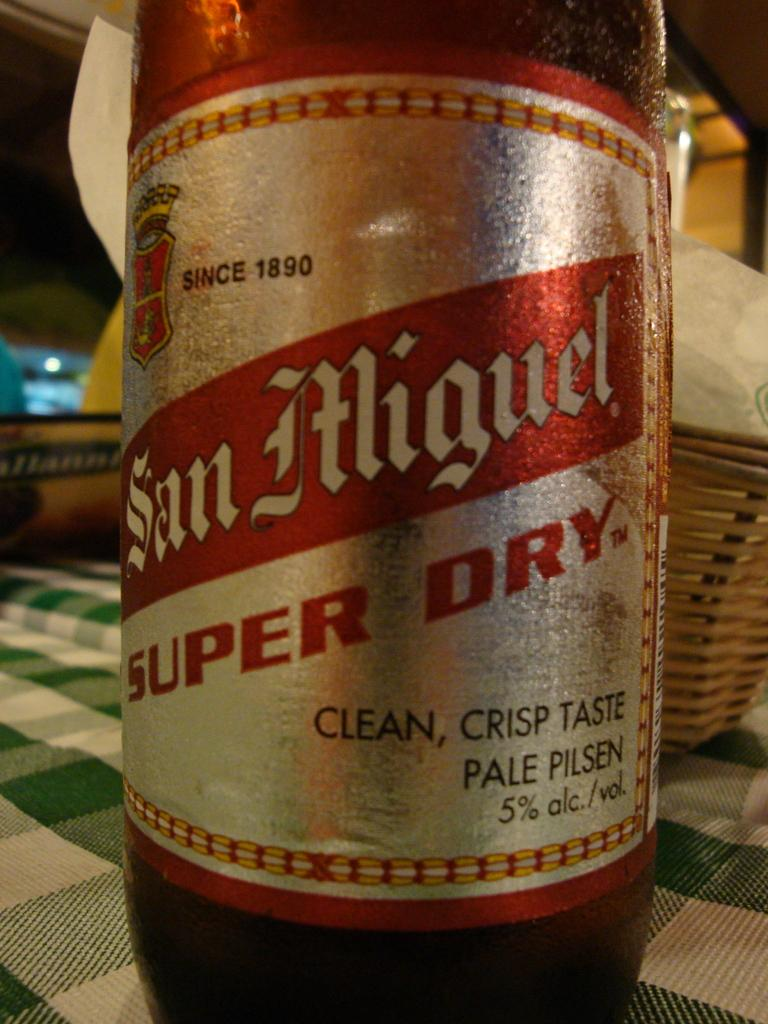<image>
Share a concise interpretation of the image provided. A San Miguel beverage on top of a table 